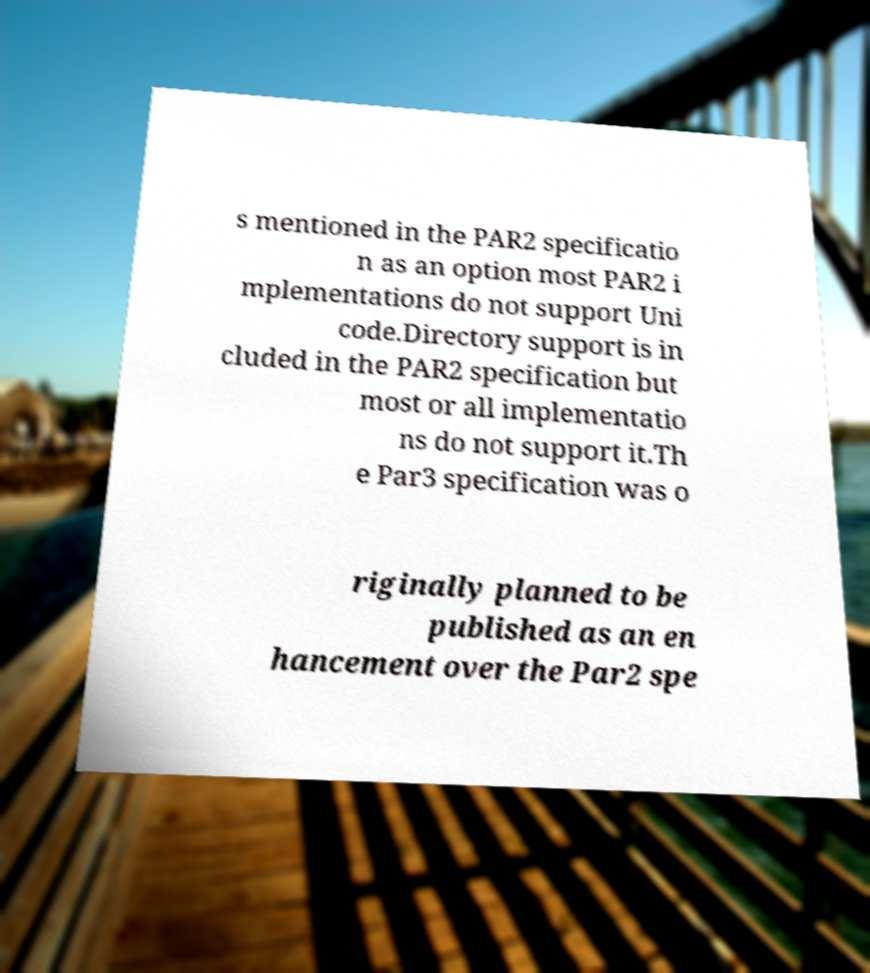Could you extract and type out the text from this image? s mentioned in the PAR2 specificatio n as an option most PAR2 i mplementations do not support Uni code.Directory support is in cluded in the PAR2 specification but most or all implementatio ns do not support it.Th e Par3 specification was o riginally planned to be published as an en hancement over the Par2 spe 